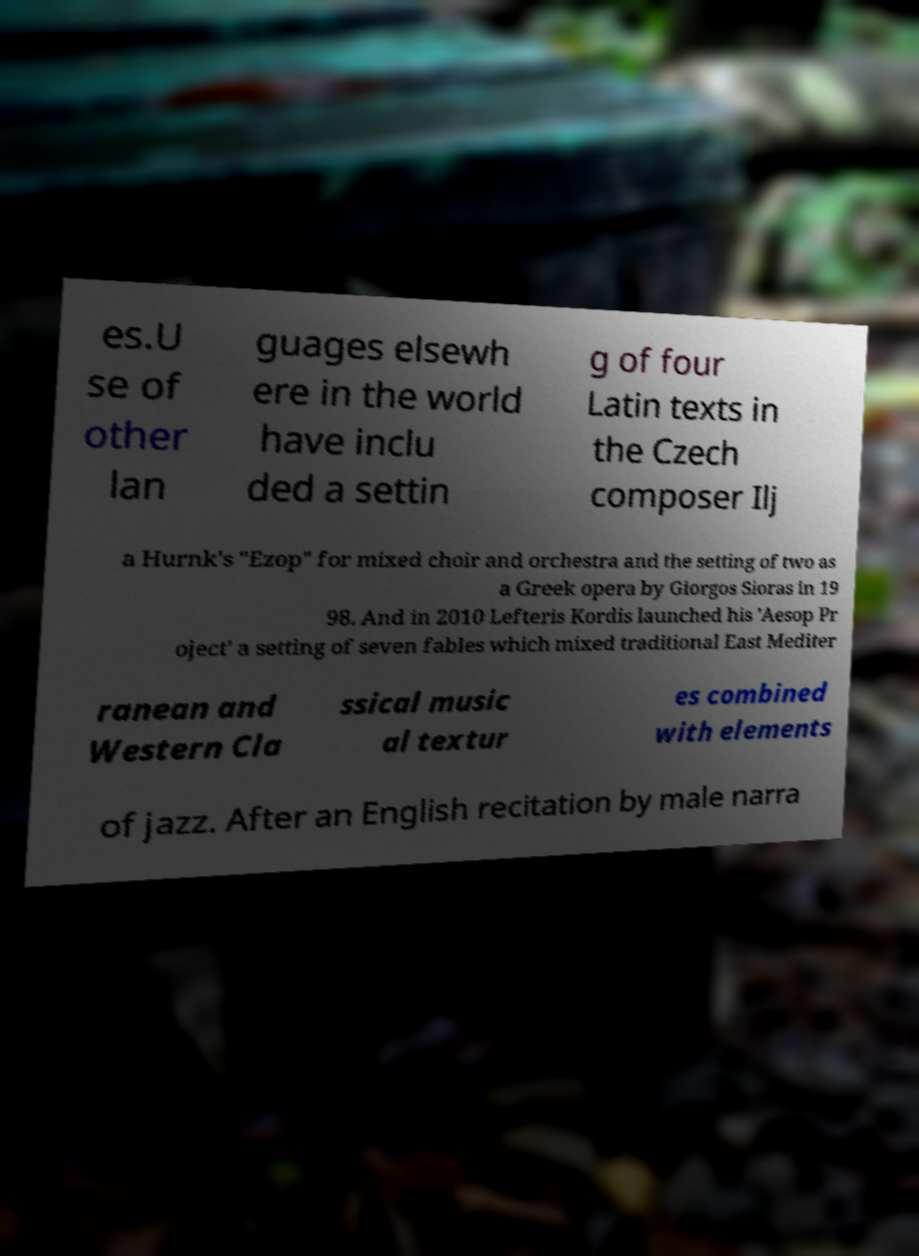For documentation purposes, I need the text within this image transcribed. Could you provide that? es.U se of other lan guages elsewh ere in the world have inclu ded a settin g of four Latin texts in the Czech composer Ilj a Hurnk's "Ezop" for mixed choir and orchestra and the setting of two as a Greek opera by Giorgos Sioras in 19 98. And in 2010 Lefteris Kordis launched his 'Aesop Pr oject' a setting of seven fables which mixed traditional East Mediter ranean and Western Cla ssical music al textur es combined with elements of jazz. After an English recitation by male narra 